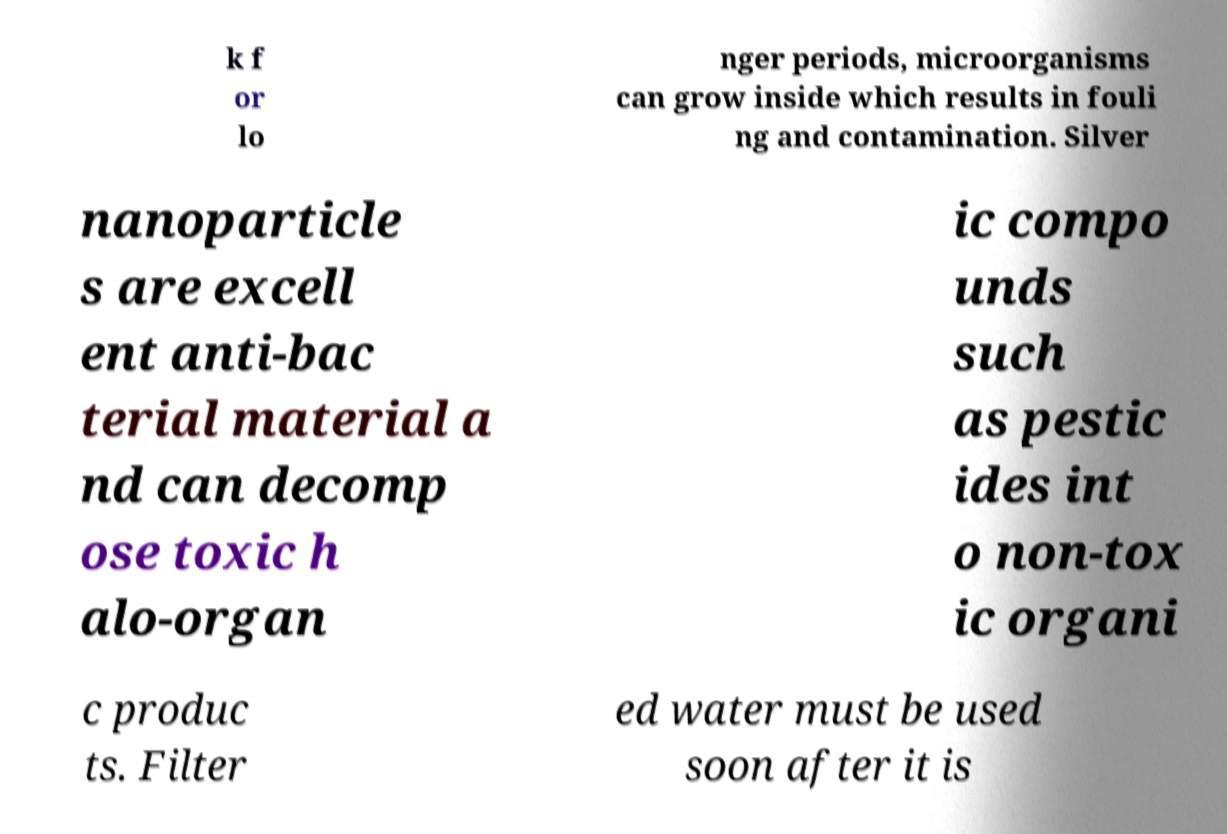I need the written content from this picture converted into text. Can you do that? k f or lo nger periods, microorganisms can grow inside which results in fouli ng and contamination. Silver nanoparticle s are excell ent anti-bac terial material a nd can decomp ose toxic h alo-organ ic compo unds such as pestic ides int o non-tox ic organi c produc ts. Filter ed water must be used soon after it is 